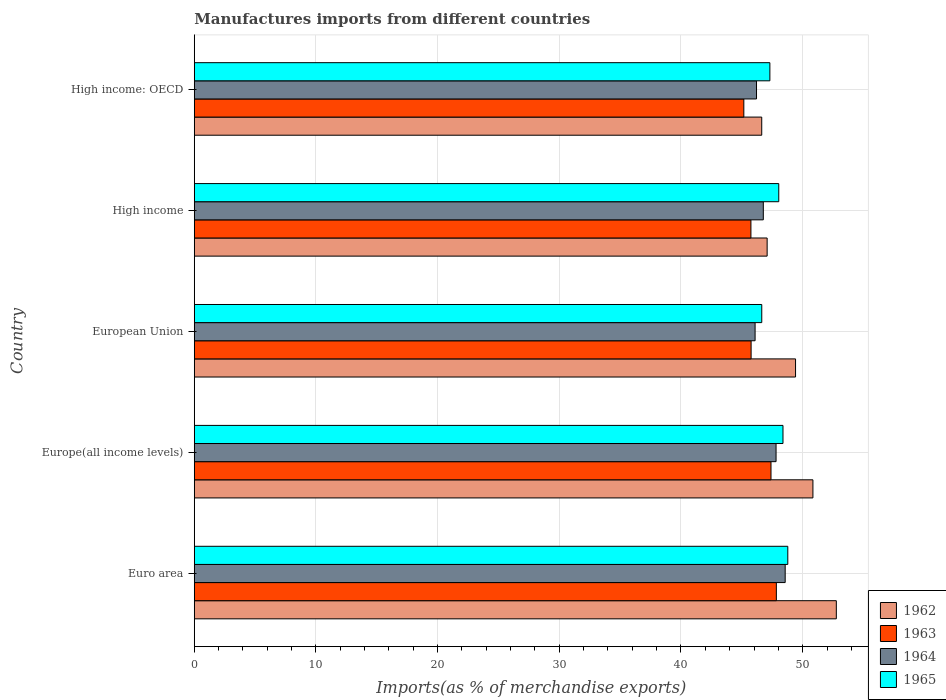Are the number of bars on each tick of the Y-axis equal?
Your response must be concise. Yes. How many bars are there on the 2nd tick from the top?
Ensure brevity in your answer.  4. What is the label of the 1st group of bars from the top?
Make the answer very short. High income: OECD. What is the percentage of imports to different countries in 1962 in European Union?
Your response must be concise. 49.41. Across all countries, what is the maximum percentage of imports to different countries in 1963?
Ensure brevity in your answer.  47.84. Across all countries, what is the minimum percentage of imports to different countries in 1963?
Offer a very short reply. 45.16. In which country was the percentage of imports to different countries in 1962 maximum?
Give a very brief answer. Euro area. In which country was the percentage of imports to different countries in 1962 minimum?
Ensure brevity in your answer.  High income: OECD. What is the total percentage of imports to different countries in 1965 in the graph?
Your answer should be compact. 239.14. What is the difference between the percentage of imports to different countries in 1964 in European Union and that in High income?
Offer a terse response. -0.68. What is the difference between the percentage of imports to different countries in 1965 in High income and the percentage of imports to different countries in 1963 in High income: OECD?
Provide a short and direct response. 2.87. What is the average percentage of imports to different countries in 1965 per country?
Make the answer very short. 47.83. What is the difference between the percentage of imports to different countries in 1964 and percentage of imports to different countries in 1962 in High income?
Your answer should be compact. -0.31. In how many countries, is the percentage of imports to different countries in 1963 greater than 28 %?
Offer a terse response. 5. What is the ratio of the percentage of imports to different countries in 1965 in Europe(all income levels) to that in High income: OECD?
Keep it short and to the point. 1.02. Is the difference between the percentage of imports to different countries in 1964 in Euro area and Europe(all income levels) greater than the difference between the percentage of imports to different countries in 1962 in Euro area and Europe(all income levels)?
Your response must be concise. No. What is the difference between the highest and the second highest percentage of imports to different countries in 1964?
Offer a very short reply. 0.75. What is the difference between the highest and the lowest percentage of imports to different countries in 1965?
Your response must be concise. 2.14. Is the sum of the percentage of imports to different countries in 1962 in Euro area and Europe(all income levels) greater than the maximum percentage of imports to different countries in 1965 across all countries?
Your answer should be compact. Yes. Is it the case that in every country, the sum of the percentage of imports to different countries in 1963 and percentage of imports to different countries in 1964 is greater than the sum of percentage of imports to different countries in 1962 and percentage of imports to different countries in 1965?
Give a very brief answer. No. What does the 3rd bar from the bottom in Europe(all income levels) represents?
Offer a very short reply. 1964. Is it the case that in every country, the sum of the percentage of imports to different countries in 1964 and percentage of imports to different countries in 1963 is greater than the percentage of imports to different countries in 1965?
Your response must be concise. Yes. How many bars are there?
Ensure brevity in your answer.  20. Are all the bars in the graph horizontal?
Make the answer very short. Yes. How many countries are there in the graph?
Provide a short and direct response. 5. Are the values on the major ticks of X-axis written in scientific E-notation?
Ensure brevity in your answer.  No. Does the graph contain any zero values?
Ensure brevity in your answer.  No. What is the title of the graph?
Offer a terse response. Manufactures imports from different countries. What is the label or title of the X-axis?
Your answer should be very brief. Imports(as % of merchandise exports). What is the Imports(as % of merchandise exports) of 1962 in Euro area?
Provide a succinct answer. 52.77. What is the Imports(as % of merchandise exports) of 1963 in Euro area?
Make the answer very short. 47.84. What is the Imports(as % of merchandise exports) of 1964 in Euro area?
Offer a terse response. 48.56. What is the Imports(as % of merchandise exports) of 1965 in Euro area?
Your answer should be very brief. 48.78. What is the Imports(as % of merchandise exports) in 1962 in Europe(all income levels)?
Offer a very short reply. 50.84. What is the Imports(as % of merchandise exports) in 1963 in Europe(all income levels)?
Your answer should be very brief. 47.4. What is the Imports(as % of merchandise exports) in 1964 in Europe(all income levels)?
Provide a short and direct response. 47.81. What is the Imports(as % of merchandise exports) in 1965 in Europe(all income levels)?
Your answer should be compact. 48.38. What is the Imports(as % of merchandise exports) in 1962 in European Union?
Provide a short and direct response. 49.41. What is the Imports(as % of merchandise exports) of 1963 in European Union?
Your answer should be compact. 45.76. What is the Imports(as % of merchandise exports) of 1964 in European Union?
Offer a terse response. 46.09. What is the Imports(as % of merchandise exports) in 1965 in European Union?
Offer a very short reply. 46.64. What is the Imports(as % of merchandise exports) of 1962 in High income?
Offer a terse response. 47.08. What is the Imports(as % of merchandise exports) in 1963 in High income?
Your response must be concise. 45.75. What is the Imports(as % of merchandise exports) in 1964 in High income?
Provide a succinct answer. 46.77. What is the Imports(as % of merchandise exports) of 1965 in High income?
Keep it short and to the point. 48.04. What is the Imports(as % of merchandise exports) of 1962 in High income: OECD?
Keep it short and to the point. 46.64. What is the Imports(as % of merchandise exports) in 1963 in High income: OECD?
Your response must be concise. 45.16. What is the Imports(as % of merchandise exports) of 1964 in High income: OECD?
Keep it short and to the point. 46.21. What is the Imports(as % of merchandise exports) in 1965 in High income: OECD?
Give a very brief answer. 47.3. Across all countries, what is the maximum Imports(as % of merchandise exports) of 1962?
Make the answer very short. 52.77. Across all countries, what is the maximum Imports(as % of merchandise exports) in 1963?
Provide a short and direct response. 47.84. Across all countries, what is the maximum Imports(as % of merchandise exports) in 1964?
Provide a short and direct response. 48.56. Across all countries, what is the maximum Imports(as % of merchandise exports) of 1965?
Your response must be concise. 48.78. Across all countries, what is the minimum Imports(as % of merchandise exports) in 1962?
Ensure brevity in your answer.  46.64. Across all countries, what is the minimum Imports(as % of merchandise exports) of 1963?
Offer a very short reply. 45.16. Across all countries, what is the minimum Imports(as % of merchandise exports) in 1964?
Ensure brevity in your answer.  46.09. Across all countries, what is the minimum Imports(as % of merchandise exports) of 1965?
Your response must be concise. 46.64. What is the total Imports(as % of merchandise exports) of 1962 in the graph?
Ensure brevity in your answer.  246.74. What is the total Imports(as % of merchandise exports) in 1963 in the graph?
Your response must be concise. 231.91. What is the total Imports(as % of merchandise exports) of 1964 in the graph?
Your answer should be very brief. 235.44. What is the total Imports(as % of merchandise exports) in 1965 in the graph?
Keep it short and to the point. 239.14. What is the difference between the Imports(as % of merchandise exports) in 1962 in Euro area and that in Europe(all income levels)?
Give a very brief answer. 1.92. What is the difference between the Imports(as % of merchandise exports) in 1963 in Euro area and that in Europe(all income levels)?
Offer a very short reply. 0.44. What is the difference between the Imports(as % of merchandise exports) in 1964 in Euro area and that in Europe(all income levels)?
Your response must be concise. 0.75. What is the difference between the Imports(as % of merchandise exports) of 1965 in Euro area and that in Europe(all income levels)?
Make the answer very short. 0.4. What is the difference between the Imports(as % of merchandise exports) in 1962 in Euro area and that in European Union?
Offer a terse response. 3.35. What is the difference between the Imports(as % of merchandise exports) of 1963 in Euro area and that in European Union?
Provide a succinct answer. 2.08. What is the difference between the Imports(as % of merchandise exports) of 1964 in Euro area and that in European Union?
Your response must be concise. 2.47. What is the difference between the Imports(as % of merchandise exports) in 1965 in Euro area and that in European Union?
Ensure brevity in your answer.  2.14. What is the difference between the Imports(as % of merchandise exports) of 1962 in Euro area and that in High income?
Offer a terse response. 5.69. What is the difference between the Imports(as % of merchandise exports) of 1963 in Euro area and that in High income?
Provide a succinct answer. 2.09. What is the difference between the Imports(as % of merchandise exports) in 1964 in Euro area and that in High income?
Offer a terse response. 1.8. What is the difference between the Imports(as % of merchandise exports) of 1965 in Euro area and that in High income?
Your answer should be very brief. 0.74. What is the difference between the Imports(as % of merchandise exports) of 1962 in Euro area and that in High income: OECD?
Your response must be concise. 6.13. What is the difference between the Imports(as % of merchandise exports) of 1963 in Euro area and that in High income: OECD?
Your answer should be very brief. 2.67. What is the difference between the Imports(as % of merchandise exports) of 1964 in Euro area and that in High income: OECD?
Provide a short and direct response. 2.36. What is the difference between the Imports(as % of merchandise exports) of 1965 in Euro area and that in High income: OECD?
Offer a very short reply. 1.47. What is the difference between the Imports(as % of merchandise exports) of 1962 in Europe(all income levels) and that in European Union?
Give a very brief answer. 1.43. What is the difference between the Imports(as % of merchandise exports) in 1963 in Europe(all income levels) and that in European Union?
Provide a succinct answer. 1.63. What is the difference between the Imports(as % of merchandise exports) of 1964 in Europe(all income levels) and that in European Union?
Offer a terse response. 1.72. What is the difference between the Imports(as % of merchandise exports) in 1965 in Europe(all income levels) and that in European Union?
Offer a terse response. 1.74. What is the difference between the Imports(as % of merchandise exports) of 1962 in Europe(all income levels) and that in High income?
Your response must be concise. 3.76. What is the difference between the Imports(as % of merchandise exports) of 1963 in Europe(all income levels) and that in High income?
Offer a terse response. 1.65. What is the difference between the Imports(as % of merchandise exports) in 1964 in Europe(all income levels) and that in High income?
Make the answer very short. 1.05. What is the difference between the Imports(as % of merchandise exports) in 1965 in Europe(all income levels) and that in High income?
Your answer should be very brief. 0.35. What is the difference between the Imports(as % of merchandise exports) in 1962 in Europe(all income levels) and that in High income: OECD?
Your answer should be compact. 4.21. What is the difference between the Imports(as % of merchandise exports) in 1963 in Europe(all income levels) and that in High income: OECD?
Offer a terse response. 2.23. What is the difference between the Imports(as % of merchandise exports) of 1964 in Europe(all income levels) and that in High income: OECD?
Your response must be concise. 1.61. What is the difference between the Imports(as % of merchandise exports) of 1965 in Europe(all income levels) and that in High income: OECD?
Your answer should be compact. 1.08. What is the difference between the Imports(as % of merchandise exports) of 1962 in European Union and that in High income?
Offer a terse response. 2.33. What is the difference between the Imports(as % of merchandise exports) in 1963 in European Union and that in High income?
Your response must be concise. 0.02. What is the difference between the Imports(as % of merchandise exports) of 1964 in European Union and that in High income?
Make the answer very short. -0.68. What is the difference between the Imports(as % of merchandise exports) in 1965 in European Union and that in High income?
Offer a terse response. -1.4. What is the difference between the Imports(as % of merchandise exports) in 1962 in European Union and that in High income: OECD?
Offer a very short reply. 2.78. What is the difference between the Imports(as % of merchandise exports) of 1963 in European Union and that in High income: OECD?
Make the answer very short. 0.6. What is the difference between the Imports(as % of merchandise exports) of 1964 in European Union and that in High income: OECD?
Your answer should be very brief. -0.12. What is the difference between the Imports(as % of merchandise exports) in 1965 in European Union and that in High income: OECD?
Your answer should be compact. -0.67. What is the difference between the Imports(as % of merchandise exports) of 1962 in High income and that in High income: OECD?
Keep it short and to the point. 0.44. What is the difference between the Imports(as % of merchandise exports) of 1963 in High income and that in High income: OECD?
Give a very brief answer. 0.58. What is the difference between the Imports(as % of merchandise exports) in 1964 in High income and that in High income: OECD?
Offer a terse response. 0.56. What is the difference between the Imports(as % of merchandise exports) of 1965 in High income and that in High income: OECD?
Your response must be concise. 0.73. What is the difference between the Imports(as % of merchandise exports) in 1962 in Euro area and the Imports(as % of merchandise exports) in 1963 in Europe(all income levels)?
Ensure brevity in your answer.  5.37. What is the difference between the Imports(as % of merchandise exports) of 1962 in Euro area and the Imports(as % of merchandise exports) of 1964 in Europe(all income levels)?
Your answer should be compact. 4.95. What is the difference between the Imports(as % of merchandise exports) of 1962 in Euro area and the Imports(as % of merchandise exports) of 1965 in Europe(all income levels)?
Provide a succinct answer. 4.38. What is the difference between the Imports(as % of merchandise exports) of 1963 in Euro area and the Imports(as % of merchandise exports) of 1964 in Europe(all income levels)?
Offer a very short reply. 0.02. What is the difference between the Imports(as % of merchandise exports) of 1963 in Euro area and the Imports(as % of merchandise exports) of 1965 in Europe(all income levels)?
Keep it short and to the point. -0.54. What is the difference between the Imports(as % of merchandise exports) in 1964 in Euro area and the Imports(as % of merchandise exports) in 1965 in Europe(all income levels)?
Offer a very short reply. 0.18. What is the difference between the Imports(as % of merchandise exports) of 1962 in Euro area and the Imports(as % of merchandise exports) of 1963 in European Union?
Offer a very short reply. 7. What is the difference between the Imports(as % of merchandise exports) in 1962 in Euro area and the Imports(as % of merchandise exports) in 1964 in European Union?
Keep it short and to the point. 6.68. What is the difference between the Imports(as % of merchandise exports) in 1962 in Euro area and the Imports(as % of merchandise exports) in 1965 in European Union?
Make the answer very short. 6.13. What is the difference between the Imports(as % of merchandise exports) of 1963 in Euro area and the Imports(as % of merchandise exports) of 1964 in European Union?
Keep it short and to the point. 1.75. What is the difference between the Imports(as % of merchandise exports) in 1963 in Euro area and the Imports(as % of merchandise exports) in 1965 in European Union?
Your answer should be very brief. 1.2. What is the difference between the Imports(as % of merchandise exports) of 1964 in Euro area and the Imports(as % of merchandise exports) of 1965 in European Union?
Your response must be concise. 1.93. What is the difference between the Imports(as % of merchandise exports) in 1962 in Euro area and the Imports(as % of merchandise exports) in 1963 in High income?
Your response must be concise. 7.02. What is the difference between the Imports(as % of merchandise exports) of 1962 in Euro area and the Imports(as % of merchandise exports) of 1964 in High income?
Ensure brevity in your answer.  6. What is the difference between the Imports(as % of merchandise exports) in 1962 in Euro area and the Imports(as % of merchandise exports) in 1965 in High income?
Keep it short and to the point. 4.73. What is the difference between the Imports(as % of merchandise exports) in 1963 in Euro area and the Imports(as % of merchandise exports) in 1964 in High income?
Ensure brevity in your answer.  1.07. What is the difference between the Imports(as % of merchandise exports) in 1963 in Euro area and the Imports(as % of merchandise exports) in 1965 in High income?
Offer a terse response. -0.2. What is the difference between the Imports(as % of merchandise exports) of 1964 in Euro area and the Imports(as % of merchandise exports) of 1965 in High income?
Offer a terse response. 0.53. What is the difference between the Imports(as % of merchandise exports) in 1962 in Euro area and the Imports(as % of merchandise exports) in 1963 in High income: OECD?
Your answer should be compact. 7.6. What is the difference between the Imports(as % of merchandise exports) of 1962 in Euro area and the Imports(as % of merchandise exports) of 1964 in High income: OECD?
Your response must be concise. 6.56. What is the difference between the Imports(as % of merchandise exports) in 1962 in Euro area and the Imports(as % of merchandise exports) in 1965 in High income: OECD?
Offer a very short reply. 5.46. What is the difference between the Imports(as % of merchandise exports) in 1963 in Euro area and the Imports(as % of merchandise exports) in 1964 in High income: OECD?
Give a very brief answer. 1.63. What is the difference between the Imports(as % of merchandise exports) of 1963 in Euro area and the Imports(as % of merchandise exports) of 1965 in High income: OECD?
Give a very brief answer. 0.53. What is the difference between the Imports(as % of merchandise exports) in 1964 in Euro area and the Imports(as % of merchandise exports) in 1965 in High income: OECD?
Provide a succinct answer. 1.26. What is the difference between the Imports(as % of merchandise exports) of 1962 in Europe(all income levels) and the Imports(as % of merchandise exports) of 1963 in European Union?
Make the answer very short. 5.08. What is the difference between the Imports(as % of merchandise exports) in 1962 in Europe(all income levels) and the Imports(as % of merchandise exports) in 1964 in European Union?
Offer a terse response. 4.75. What is the difference between the Imports(as % of merchandise exports) in 1962 in Europe(all income levels) and the Imports(as % of merchandise exports) in 1965 in European Union?
Offer a terse response. 4.2. What is the difference between the Imports(as % of merchandise exports) of 1963 in Europe(all income levels) and the Imports(as % of merchandise exports) of 1964 in European Union?
Make the answer very short. 1.31. What is the difference between the Imports(as % of merchandise exports) of 1963 in Europe(all income levels) and the Imports(as % of merchandise exports) of 1965 in European Union?
Provide a succinct answer. 0.76. What is the difference between the Imports(as % of merchandise exports) in 1964 in Europe(all income levels) and the Imports(as % of merchandise exports) in 1965 in European Union?
Ensure brevity in your answer.  1.18. What is the difference between the Imports(as % of merchandise exports) in 1962 in Europe(all income levels) and the Imports(as % of merchandise exports) in 1963 in High income?
Your answer should be very brief. 5.1. What is the difference between the Imports(as % of merchandise exports) in 1962 in Europe(all income levels) and the Imports(as % of merchandise exports) in 1964 in High income?
Your response must be concise. 4.08. What is the difference between the Imports(as % of merchandise exports) in 1962 in Europe(all income levels) and the Imports(as % of merchandise exports) in 1965 in High income?
Give a very brief answer. 2.81. What is the difference between the Imports(as % of merchandise exports) of 1963 in Europe(all income levels) and the Imports(as % of merchandise exports) of 1964 in High income?
Keep it short and to the point. 0.63. What is the difference between the Imports(as % of merchandise exports) of 1963 in Europe(all income levels) and the Imports(as % of merchandise exports) of 1965 in High income?
Keep it short and to the point. -0.64. What is the difference between the Imports(as % of merchandise exports) of 1964 in Europe(all income levels) and the Imports(as % of merchandise exports) of 1965 in High income?
Make the answer very short. -0.22. What is the difference between the Imports(as % of merchandise exports) in 1962 in Europe(all income levels) and the Imports(as % of merchandise exports) in 1963 in High income: OECD?
Provide a short and direct response. 5.68. What is the difference between the Imports(as % of merchandise exports) in 1962 in Europe(all income levels) and the Imports(as % of merchandise exports) in 1964 in High income: OECD?
Offer a terse response. 4.63. What is the difference between the Imports(as % of merchandise exports) of 1962 in Europe(all income levels) and the Imports(as % of merchandise exports) of 1965 in High income: OECD?
Offer a very short reply. 3.54. What is the difference between the Imports(as % of merchandise exports) in 1963 in Europe(all income levels) and the Imports(as % of merchandise exports) in 1964 in High income: OECD?
Provide a short and direct response. 1.19. What is the difference between the Imports(as % of merchandise exports) of 1963 in Europe(all income levels) and the Imports(as % of merchandise exports) of 1965 in High income: OECD?
Ensure brevity in your answer.  0.09. What is the difference between the Imports(as % of merchandise exports) in 1964 in Europe(all income levels) and the Imports(as % of merchandise exports) in 1965 in High income: OECD?
Give a very brief answer. 0.51. What is the difference between the Imports(as % of merchandise exports) in 1962 in European Union and the Imports(as % of merchandise exports) in 1963 in High income?
Your response must be concise. 3.67. What is the difference between the Imports(as % of merchandise exports) in 1962 in European Union and the Imports(as % of merchandise exports) in 1964 in High income?
Your answer should be compact. 2.65. What is the difference between the Imports(as % of merchandise exports) in 1962 in European Union and the Imports(as % of merchandise exports) in 1965 in High income?
Make the answer very short. 1.38. What is the difference between the Imports(as % of merchandise exports) of 1963 in European Union and the Imports(as % of merchandise exports) of 1964 in High income?
Keep it short and to the point. -1. What is the difference between the Imports(as % of merchandise exports) of 1963 in European Union and the Imports(as % of merchandise exports) of 1965 in High income?
Your answer should be compact. -2.27. What is the difference between the Imports(as % of merchandise exports) in 1964 in European Union and the Imports(as % of merchandise exports) in 1965 in High income?
Provide a short and direct response. -1.94. What is the difference between the Imports(as % of merchandise exports) in 1962 in European Union and the Imports(as % of merchandise exports) in 1963 in High income: OECD?
Offer a terse response. 4.25. What is the difference between the Imports(as % of merchandise exports) in 1962 in European Union and the Imports(as % of merchandise exports) in 1964 in High income: OECD?
Give a very brief answer. 3.21. What is the difference between the Imports(as % of merchandise exports) of 1962 in European Union and the Imports(as % of merchandise exports) of 1965 in High income: OECD?
Offer a terse response. 2.11. What is the difference between the Imports(as % of merchandise exports) in 1963 in European Union and the Imports(as % of merchandise exports) in 1964 in High income: OECD?
Provide a succinct answer. -0.44. What is the difference between the Imports(as % of merchandise exports) in 1963 in European Union and the Imports(as % of merchandise exports) in 1965 in High income: OECD?
Make the answer very short. -1.54. What is the difference between the Imports(as % of merchandise exports) of 1964 in European Union and the Imports(as % of merchandise exports) of 1965 in High income: OECD?
Your response must be concise. -1.21. What is the difference between the Imports(as % of merchandise exports) of 1962 in High income and the Imports(as % of merchandise exports) of 1963 in High income: OECD?
Your response must be concise. 1.92. What is the difference between the Imports(as % of merchandise exports) in 1962 in High income and the Imports(as % of merchandise exports) in 1964 in High income: OECD?
Make the answer very short. 0.87. What is the difference between the Imports(as % of merchandise exports) of 1962 in High income and the Imports(as % of merchandise exports) of 1965 in High income: OECD?
Offer a terse response. -0.22. What is the difference between the Imports(as % of merchandise exports) in 1963 in High income and the Imports(as % of merchandise exports) in 1964 in High income: OECD?
Give a very brief answer. -0.46. What is the difference between the Imports(as % of merchandise exports) in 1963 in High income and the Imports(as % of merchandise exports) in 1965 in High income: OECD?
Offer a terse response. -1.56. What is the difference between the Imports(as % of merchandise exports) of 1964 in High income and the Imports(as % of merchandise exports) of 1965 in High income: OECD?
Ensure brevity in your answer.  -0.54. What is the average Imports(as % of merchandise exports) in 1962 per country?
Your answer should be compact. 49.35. What is the average Imports(as % of merchandise exports) of 1963 per country?
Offer a terse response. 46.38. What is the average Imports(as % of merchandise exports) in 1964 per country?
Make the answer very short. 47.09. What is the average Imports(as % of merchandise exports) of 1965 per country?
Make the answer very short. 47.83. What is the difference between the Imports(as % of merchandise exports) of 1962 and Imports(as % of merchandise exports) of 1963 in Euro area?
Your response must be concise. 4.93. What is the difference between the Imports(as % of merchandise exports) of 1962 and Imports(as % of merchandise exports) of 1964 in Euro area?
Your response must be concise. 4.2. What is the difference between the Imports(as % of merchandise exports) of 1962 and Imports(as % of merchandise exports) of 1965 in Euro area?
Ensure brevity in your answer.  3.99. What is the difference between the Imports(as % of merchandise exports) in 1963 and Imports(as % of merchandise exports) in 1964 in Euro area?
Offer a very short reply. -0.73. What is the difference between the Imports(as % of merchandise exports) of 1963 and Imports(as % of merchandise exports) of 1965 in Euro area?
Keep it short and to the point. -0.94. What is the difference between the Imports(as % of merchandise exports) in 1964 and Imports(as % of merchandise exports) in 1965 in Euro area?
Provide a short and direct response. -0.21. What is the difference between the Imports(as % of merchandise exports) of 1962 and Imports(as % of merchandise exports) of 1963 in Europe(all income levels)?
Provide a succinct answer. 3.45. What is the difference between the Imports(as % of merchandise exports) in 1962 and Imports(as % of merchandise exports) in 1964 in Europe(all income levels)?
Ensure brevity in your answer.  3.03. What is the difference between the Imports(as % of merchandise exports) of 1962 and Imports(as % of merchandise exports) of 1965 in Europe(all income levels)?
Make the answer very short. 2.46. What is the difference between the Imports(as % of merchandise exports) in 1963 and Imports(as % of merchandise exports) in 1964 in Europe(all income levels)?
Keep it short and to the point. -0.42. What is the difference between the Imports(as % of merchandise exports) in 1963 and Imports(as % of merchandise exports) in 1965 in Europe(all income levels)?
Keep it short and to the point. -0.99. What is the difference between the Imports(as % of merchandise exports) of 1964 and Imports(as % of merchandise exports) of 1965 in Europe(all income levels)?
Ensure brevity in your answer.  -0.57. What is the difference between the Imports(as % of merchandise exports) in 1962 and Imports(as % of merchandise exports) in 1963 in European Union?
Your answer should be compact. 3.65. What is the difference between the Imports(as % of merchandise exports) of 1962 and Imports(as % of merchandise exports) of 1964 in European Union?
Offer a terse response. 3.32. What is the difference between the Imports(as % of merchandise exports) in 1962 and Imports(as % of merchandise exports) in 1965 in European Union?
Ensure brevity in your answer.  2.78. What is the difference between the Imports(as % of merchandise exports) of 1963 and Imports(as % of merchandise exports) of 1964 in European Union?
Provide a short and direct response. -0.33. What is the difference between the Imports(as % of merchandise exports) in 1963 and Imports(as % of merchandise exports) in 1965 in European Union?
Offer a very short reply. -0.88. What is the difference between the Imports(as % of merchandise exports) in 1964 and Imports(as % of merchandise exports) in 1965 in European Union?
Offer a very short reply. -0.55. What is the difference between the Imports(as % of merchandise exports) in 1962 and Imports(as % of merchandise exports) in 1963 in High income?
Ensure brevity in your answer.  1.33. What is the difference between the Imports(as % of merchandise exports) of 1962 and Imports(as % of merchandise exports) of 1964 in High income?
Make the answer very short. 0.31. What is the difference between the Imports(as % of merchandise exports) of 1962 and Imports(as % of merchandise exports) of 1965 in High income?
Offer a terse response. -0.96. What is the difference between the Imports(as % of merchandise exports) of 1963 and Imports(as % of merchandise exports) of 1964 in High income?
Provide a succinct answer. -1.02. What is the difference between the Imports(as % of merchandise exports) in 1963 and Imports(as % of merchandise exports) in 1965 in High income?
Keep it short and to the point. -2.29. What is the difference between the Imports(as % of merchandise exports) of 1964 and Imports(as % of merchandise exports) of 1965 in High income?
Ensure brevity in your answer.  -1.27. What is the difference between the Imports(as % of merchandise exports) in 1962 and Imports(as % of merchandise exports) in 1963 in High income: OECD?
Give a very brief answer. 1.47. What is the difference between the Imports(as % of merchandise exports) of 1962 and Imports(as % of merchandise exports) of 1964 in High income: OECD?
Make the answer very short. 0.43. What is the difference between the Imports(as % of merchandise exports) of 1962 and Imports(as % of merchandise exports) of 1965 in High income: OECD?
Your response must be concise. -0.67. What is the difference between the Imports(as % of merchandise exports) of 1963 and Imports(as % of merchandise exports) of 1964 in High income: OECD?
Give a very brief answer. -1.04. What is the difference between the Imports(as % of merchandise exports) in 1963 and Imports(as % of merchandise exports) in 1965 in High income: OECD?
Your answer should be compact. -2.14. What is the difference between the Imports(as % of merchandise exports) of 1964 and Imports(as % of merchandise exports) of 1965 in High income: OECD?
Offer a terse response. -1.1. What is the ratio of the Imports(as % of merchandise exports) in 1962 in Euro area to that in Europe(all income levels)?
Give a very brief answer. 1.04. What is the ratio of the Imports(as % of merchandise exports) of 1963 in Euro area to that in Europe(all income levels)?
Your answer should be very brief. 1.01. What is the ratio of the Imports(as % of merchandise exports) of 1964 in Euro area to that in Europe(all income levels)?
Keep it short and to the point. 1.02. What is the ratio of the Imports(as % of merchandise exports) in 1965 in Euro area to that in Europe(all income levels)?
Your answer should be very brief. 1.01. What is the ratio of the Imports(as % of merchandise exports) of 1962 in Euro area to that in European Union?
Provide a succinct answer. 1.07. What is the ratio of the Imports(as % of merchandise exports) in 1963 in Euro area to that in European Union?
Offer a terse response. 1.05. What is the ratio of the Imports(as % of merchandise exports) in 1964 in Euro area to that in European Union?
Your answer should be compact. 1.05. What is the ratio of the Imports(as % of merchandise exports) in 1965 in Euro area to that in European Union?
Ensure brevity in your answer.  1.05. What is the ratio of the Imports(as % of merchandise exports) of 1962 in Euro area to that in High income?
Provide a short and direct response. 1.12. What is the ratio of the Imports(as % of merchandise exports) in 1963 in Euro area to that in High income?
Make the answer very short. 1.05. What is the ratio of the Imports(as % of merchandise exports) in 1964 in Euro area to that in High income?
Offer a very short reply. 1.04. What is the ratio of the Imports(as % of merchandise exports) of 1965 in Euro area to that in High income?
Make the answer very short. 1.02. What is the ratio of the Imports(as % of merchandise exports) of 1962 in Euro area to that in High income: OECD?
Offer a very short reply. 1.13. What is the ratio of the Imports(as % of merchandise exports) in 1963 in Euro area to that in High income: OECD?
Keep it short and to the point. 1.06. What is the ratio of the Imports(as % of merchandise exports) in 1964 in Euro area to that in High income: OECD?
Offer a terse response. 1.05. What is the ratio of the Imports(as % of merchandise exports) in 1965 in Euro area to that in High income: OECD?
Your answer should be very brief. 1.03. What is the ratio of the Imports(as % of merchandise exports) in 1962 in Europe(all income levels) to that in European Union?
Your answer should be very brief. 1.03. What is the ratio of the Imports(as % of merchandise exports) of 1963 in Europe(all income levels) to that in European Union?
Your answer should be compact. 1.04. What is the ratio of the Imports(as % of merchandise exports) in 1964 in Europe(all income levels) to that in European Union?
Offer a terse response. 1.04. What is the ratio of the Imports(as % of merchandise exports) in 1965 in Europe(all income levels) to that in European Union?
Provide a succinct answer. 1.04. What is the ratio of the Imports(as % of merchandise exports) of 1962 in Europe(all income levels) to that in High income?
Provide a succinct answer. 1.08. What is the ratio of the Imports(as % of merchandise exports) of 1963 in Europe(all income levels) to that in High income?
Offer a terse response. 1.04. What is the ratio of the Imports(as % of merchandise exports) of 1964 in Europe(all income levels) to that in High income?
Give a very brief answer. 1.02. What is the ratio of the Imports(as % of merchandise exports) in 1962 in Europe(all income levels) to that in High income: OECD?
Your response must be concise. 1.09. What is the ratio of the Imports(as % of merchandise exports) in 1963 in Europe(all income levels) to that in High income: OECD?
Provide a succinct answer. 1.05. What is the ratio of the Imports(as % of merchandise exports) in 1964 in Europe(all income levels) to that in High income: OECD?
Keep it short and to the point. 1.03. What is the ratio of the Imports(as % of merchandise exports) of 1965 in Europe(all income levels) to that in High income: OECD?
Offer a very short reply. 1.02. What is the ratio of the Imports(as % of merchandise exports) of 1962 in European Union to that in High income?
Your answer should be compact. 1.05. What is the ratio of the Imports(as % of merchandise exports) of 1963 in European Union to that in High income?
Ensure brevity in your answer.  1. What is the ratio of the Imports(as % of merchandise exports) of 1964 in European Union to that in High income?
Give a very brief answer. 0.99. What is the ratio of the Imports(as % of merchandise exports) in 1965 in European Union to that in High income?
Make the answer very short. 0.97. What is the ratio of the Imports(as % of merchandise exports) in 1962 in European Union to that in High income: OECD?
Offer a terse response. 1.06. What is the ratio of the Imports(as % of merchandise exports) in 1963 in European Union to that in High income: OECD?
Your answer should be compact. 1.01. What is the ratio of the Imports(as % of merchandise exports) in 1964 in European Union to that in High income: OECD?
Provide a succinct answer. 1. What is the ratio of the Imports(as % of merchandise exports) in 1965 in European Union to that in High income: OECD?
Provide a succinct answer. 0.99. What is the ratio of the Imports(as % of merchandise exports) of 1962 in High income to that in High income: OECD?
Offer a terse response. 1.01. What is the ratio of the Imports(as % of merchandise exports) in 1963 in High income to that in High income: OECD?
Ensure brevity in your answer.  1.01. What is the ratio of the Imports(as % of merchandise exports) in 1964 in High income to that in High income: OECD?
Your response must be concise. 1.01. What is the ratio of the Imports(as % of merchandise exports) in 1965 in High income to that in High income: OECD?
Keep it short and to the point. 1.02. What is the difference between the highest and the second highest Imports(as % of merchandise exports) of 1962?
Make the answer very short. 1.92. What is the difference between the highest and the second highest Imports(as % of merchandise exports) of 1963?
Provide a short and direct response. 0.44. What is the difference between the highest and the second highest Imports(as % of merchandise exports) in 1965?
Offer a terse response. 0.4. What is the difference between the highest and the lowest Imports(as % of merchandise exports) in 1962?
Provide a succinct answer. 6.13. What is the difference between the highest and the lowest Imports(as % of merchandise exports) of 1963?
Ensure brevity in your answer.  2.67. What is the difference between the highest and the lowest Imports(as % of merchandise exports) in 1964?
Make the answer very short. 2.47. What is the difference between the highest and the lowest Imports(as % of merchandise exports) of 1965?
Offer a very short reply. 2.14. 